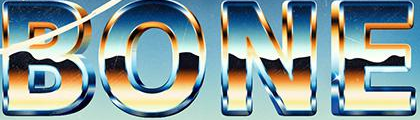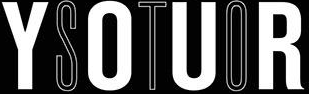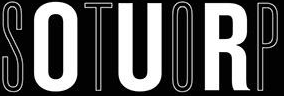Read the text content from these images in order, separated by a semicolon. BONE; YOUR; STOP 